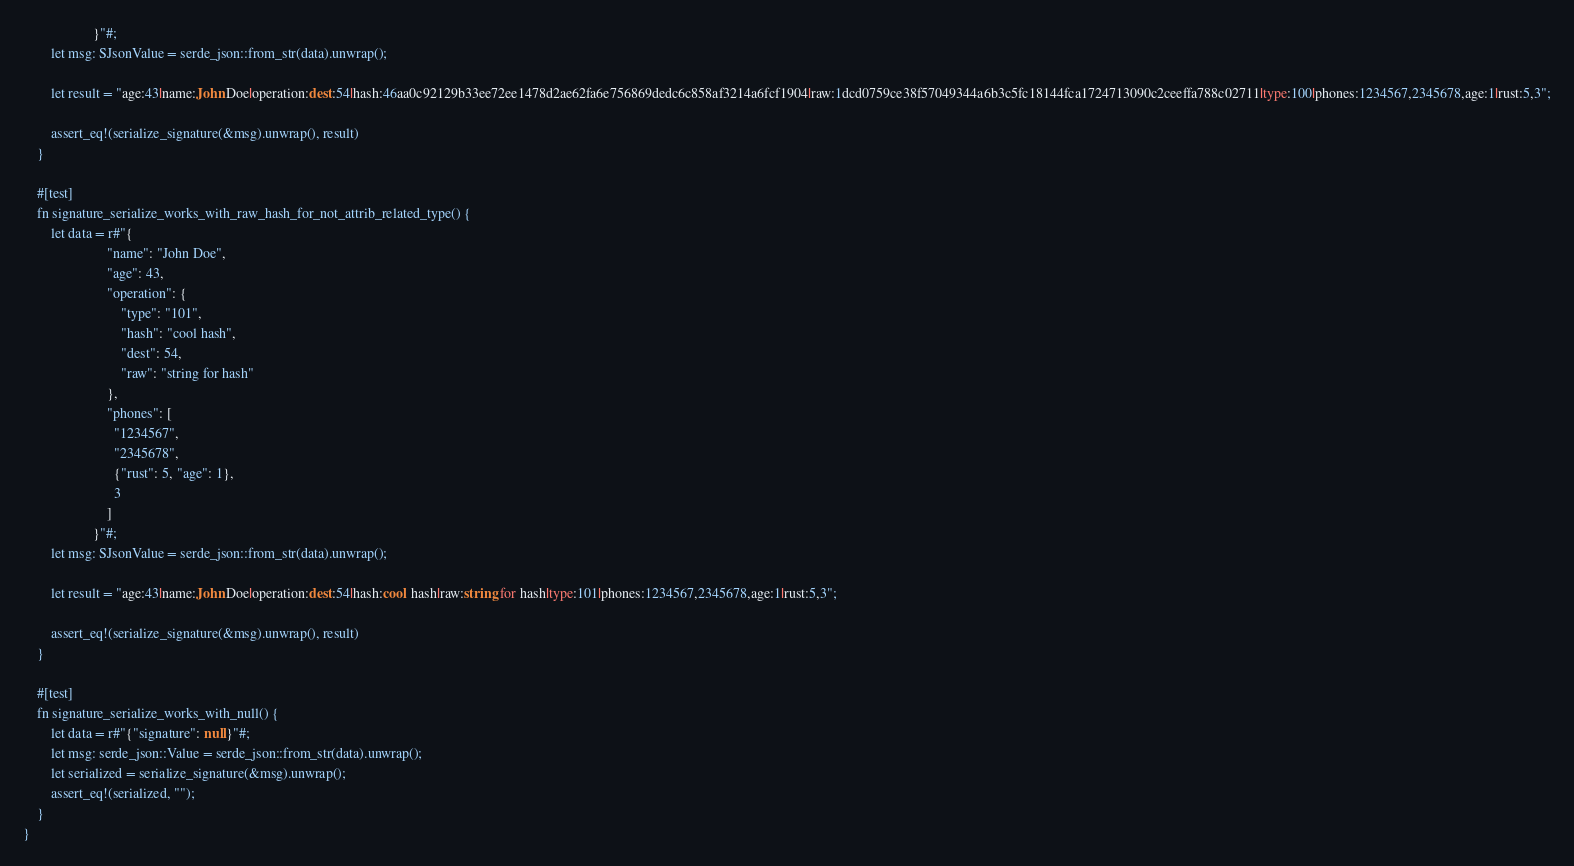<code> <loc_0><loc_0><loc_500><loc_500><_Rust_>                    }"#;
        let msg: SJsonValue = serde_json::from_str(data).unwrap();

        let result = "age:43|name:John Doe|operation:dest:54|hash:46aa0c92129b33ee72ee1478d2ae62fa6e756869dedc6c858af3214a6fcf1904|raw:1dcd0759ce38f57049344a6b3c5fc18144fca1724713090c2ceeffa788c02711|type:100|phones:1234567,2345678,age:1|rust:5,3";

        assert_eq!(serialize_signature(&msg).unwrap(), result)
    }

    #[test]
    fn signature_serialize_works_with_raw_hash_for_not_attrib_related_type() {
        let data = r#"{
                        "name": "John Doe",
                        "age": 43,
                        "operation": {
                            "type": "101",
                            "hash": "cool hash",
                            "dest": 54,
                            "raw": "string for hash"
                        },
                        "phones": [
                          "1234567",
                          "2345678",
                          {"rust": 5, "age": 1},
                          3
                        ]
                    }"#;
        let msg: SJsonValue = serde_json::from_str(data).unwrap();

        let result = "age:43|name:John Doe|operation:dest:54|hash:cool hash|raw:string for hash|type:101|phones:1234567,2345678,age:1|rust:5,3";

        assert_eq!(serialize_signature(&msg).unwrap(), result)
    }

    #[test]
    fn signature_serialize_works_with_null() {
        let data = r#"{"signature": null}"#;
        let msg: serde_json::Value = serde_json::from_str(data).unwrap();
        let serialized = serialize_signature(&msg).unwrap();
        assert_eq!(serialized, "");
    }
}
</code> 